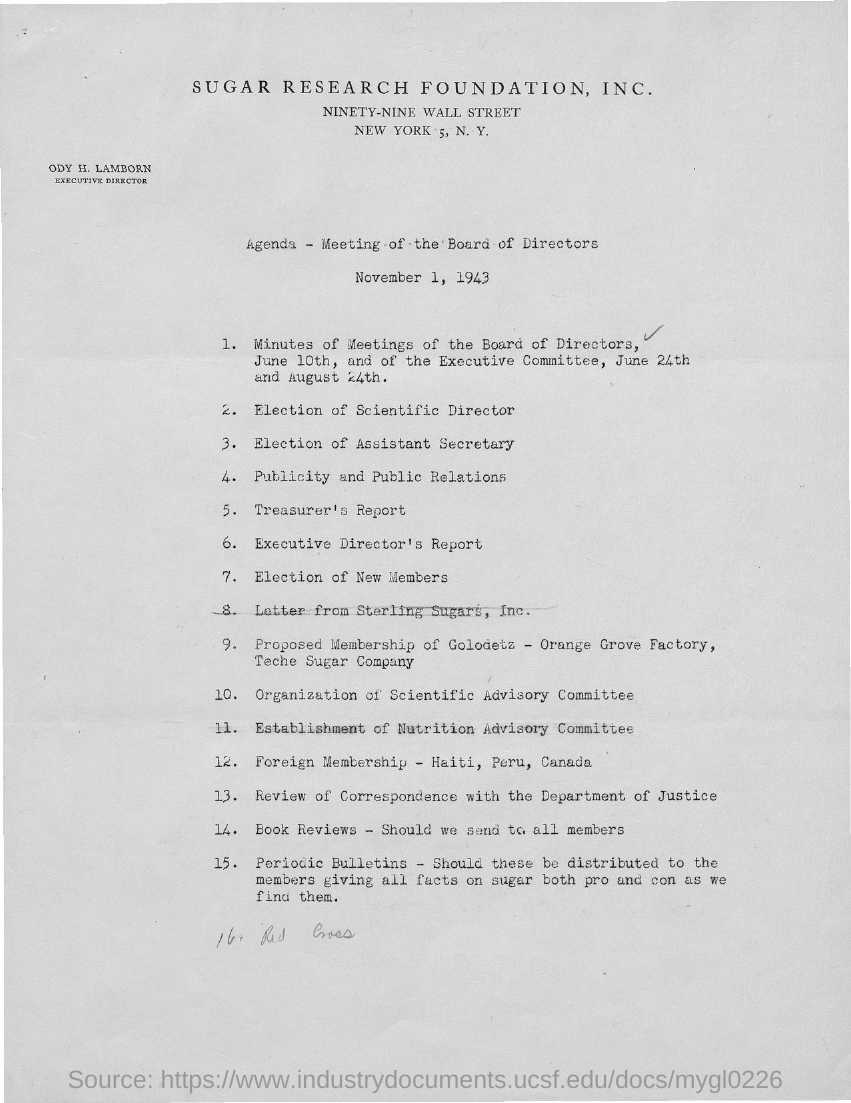Which company is mentioned in the header of the document?
Your answer should be very brief. SUGAR RESEARCH FOUNDATION, INC. What is the designation of ODY H. LAMBORN?
Offer a very short reply. EXECUTIVE DIRECTOR. 